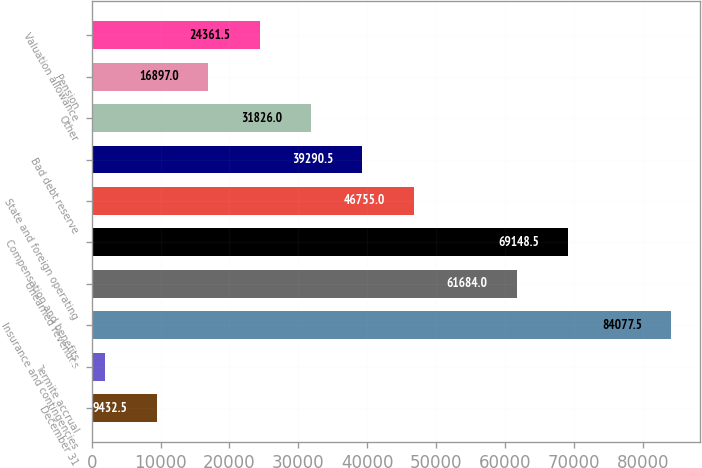Convert chart. <chart><loc_0><loc_0><loc_500><loc_500><bar_chart><fcel>December 31<fcel>Termite accrual<fcel>Insurance and contingencies<fcel>Unearned revenues<fcel>Compensation and benefits<fcel>State and foreign operating<fcel>Bad debt reserve<fcel>Other<fcel>Pension<fcel>Valuation allowance<nl><fcel>9432.5<fcel>1968<fcel>84077.5<fcel>61684<fcel>69148.5<fcel>46755<fcel>39290.5<fcel>31826<fcel>16897<fcel>24361.5<nl></chart> 